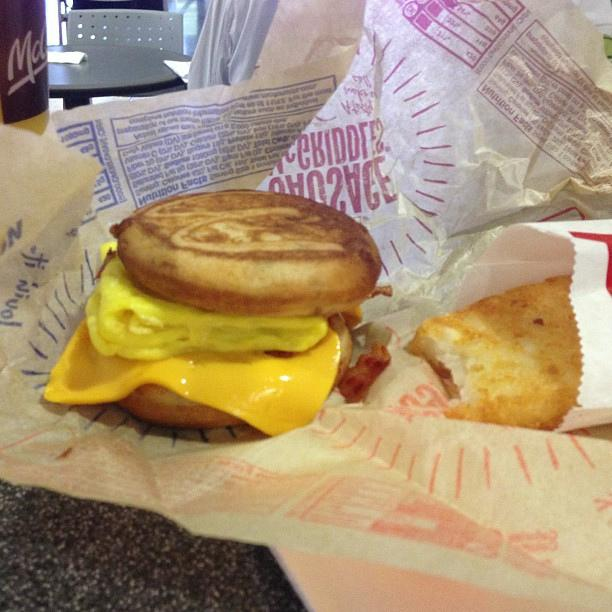What is the yellow item near the egg? Please explain your reasoning. cheese. This is a slice of dairy product 